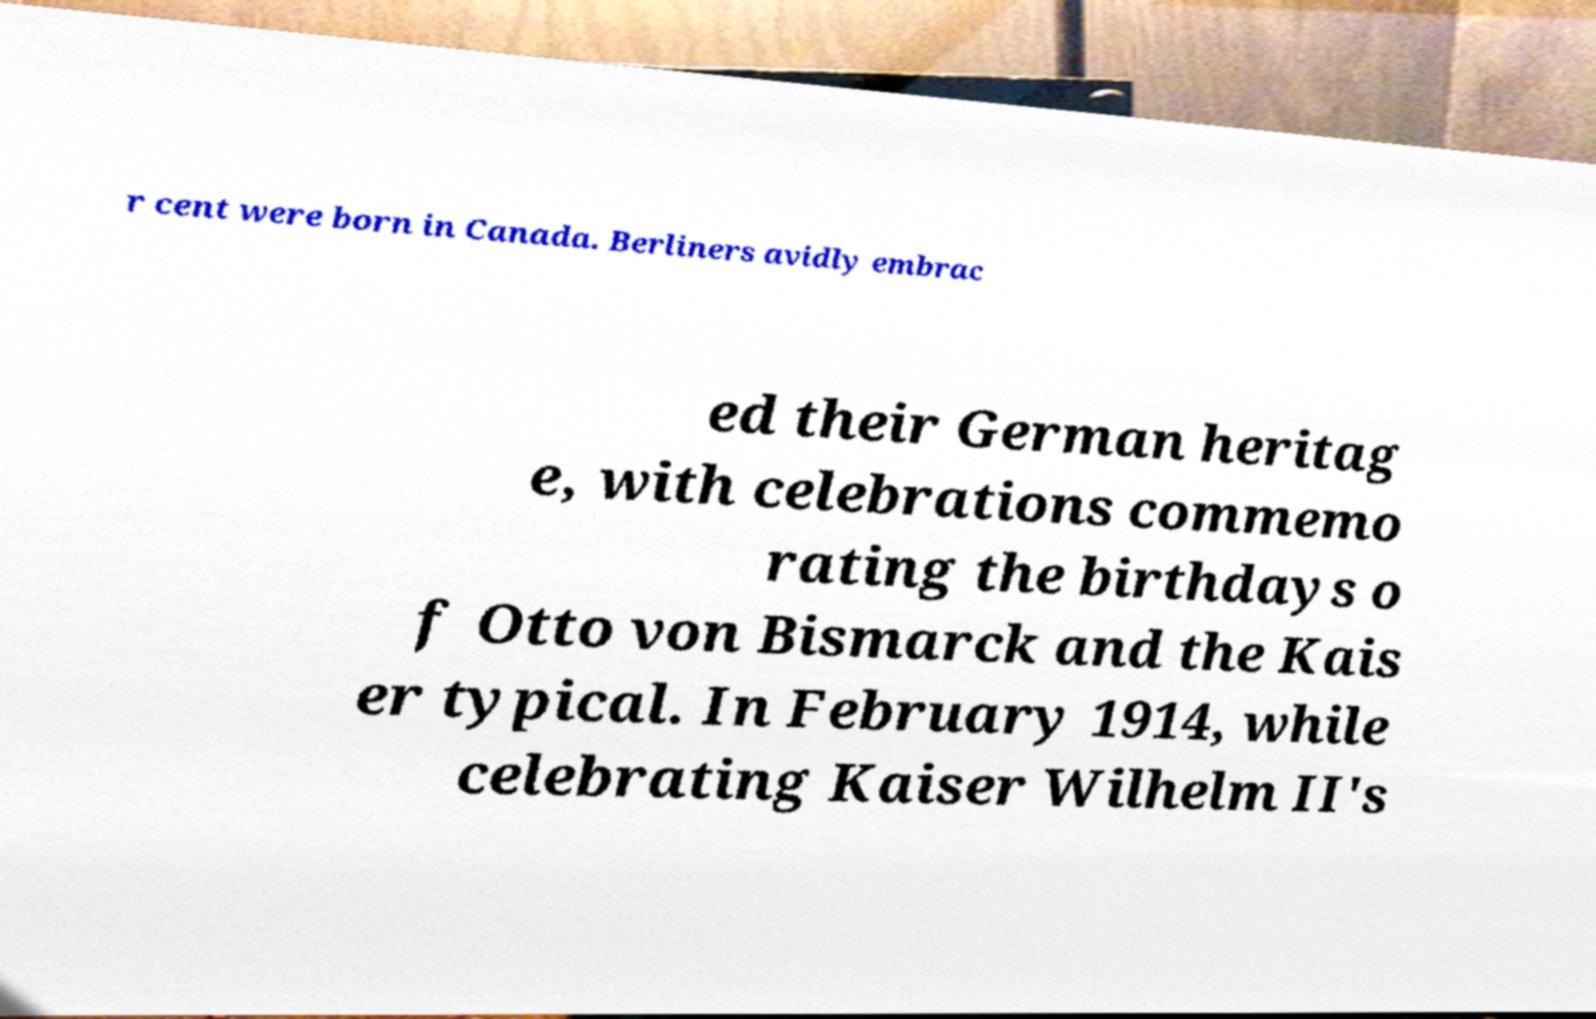Please identify and transcribe the text found in this image. r cent were born in Canada. Berliners avidly embrac ed their German heritag e, with celebrations commemo rating the birthdays o f Otto von Bismarck and the Kais er typical. In February 1914, while celebrating Kaiser Wilhelm II's 